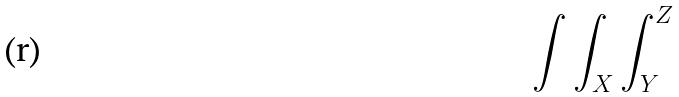<formula> <loc_0><loc_0><loc_500><loc_500>\int \int _ { X } \int _ { Y } ^ { Z }</formula> 